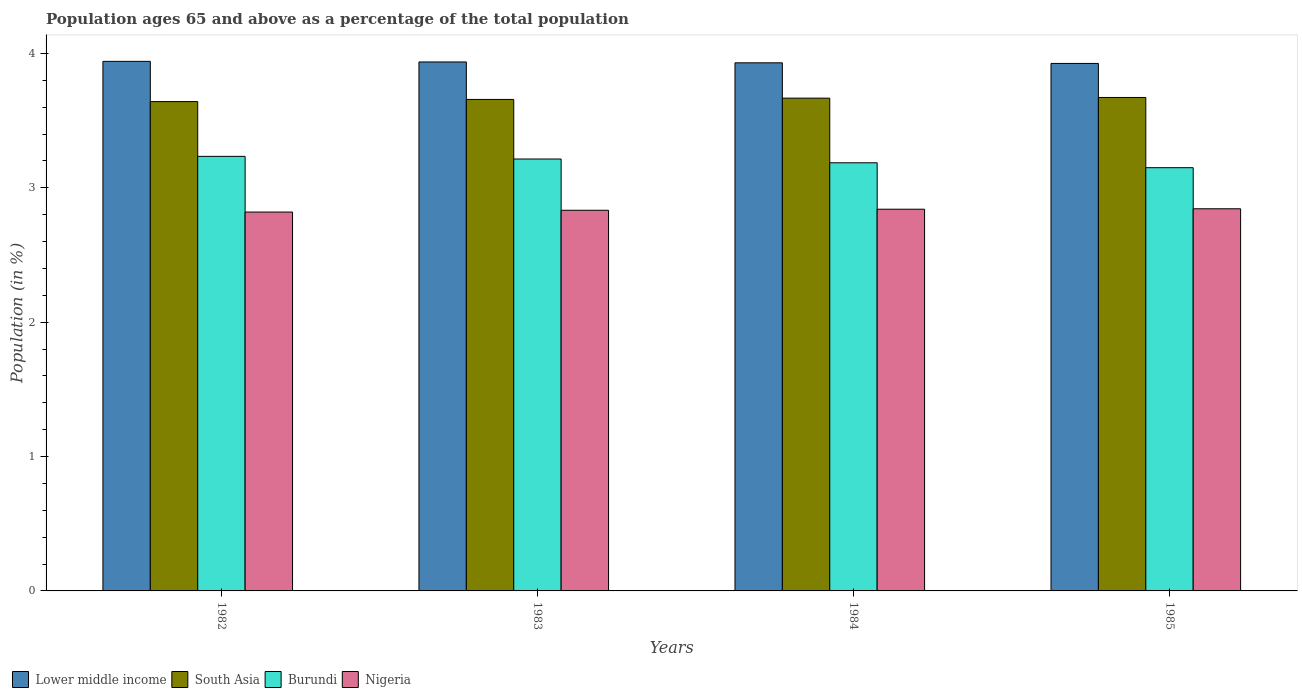How many bars are there on the 4th tick from the left?
Your answer should be very brief. 4. How many bars are there on the 1st tick from the right?
Provide a succinct answer. 4. What is the label of the 1st group of bars from the left?
Provide a short and direct response. 1982. In how many cases, is the number of bars for a given year not equal to the number of legend labels?
Offer a terse response. 0. What is the percentage of the population ages 65 and above in South Asia in 1985?
Make the answer very short. 3.67. Across all years, what is the maximum percentage of the population ages 65 and above in Burundi?
Provide a succinct answer. 3.23. Across all years, what is the minimum percentage of the population ages 65 and above in Burundi?
Your answer should be very brief. 3.15. In which year was the percentage of the population ages 65 and above in Lower middle income maximum?
Your answer should be very brief. 1982. What is the total percentage of the population ages 65 and above in Burundi in the graph?
Give a very brief answer. 12.78. What is the difference between the percentage of the population ages 65 and above in South Asia in 1983 and that in 1984?
Ensure brevity in your answer.  -0.01. What is the difference between the percentage of the population ages 65 and above in Lower middle income in 1983 and the percentage of the population ages 65 and above in Nigeria in 1984?
Provide a short and direct response. 1.1. What is the average percentage of the population ages 65 and above in South Asia per year?
Offer a terse response. 3.66. In the year 1985, what is the difference between the percentage of the population ages 65 and above in South Asia and percentage of the population ages 65 and above in Nigeria?
Your response must be concise. 0.83. What is the ratio of the percentage of the population ages 65 and above in South Asia in 1982 to that in 1985?
Give a very brief answer. 0.99. Is the percentage of the population ages 65 and above in Lower middle income in 1982 less than that in 1984?
Make the answer very short. No. What is the difference between the highest and the second highest percentage of the population ages 65 and above in Nigeria?
Give a very brief answer. 0. What is the difference between the highest and the lowest percentage of the population ages 65 and above in Nigeria?
Your answer should be very brief. 0.02. In how many years, is the percentage of the population ages 65 and above in Burundi greater than the average percentage of the population ages 65 and above in Burundi taken over all years?
Offer a very short reply. 2. What does the 3rd bar from the left in 1984 represents?
Your answer should be compact. Burundi. What does the 4th bar from the right in 1983 represents?
Provide a short and direct response. Lower middle income. Is it the case that in every year, the sum of the percentage of the population ages 65 and above in South Asia and percentage of the population ages 65 and above in Lower middle income is greater than the percentage of the population ages 65 and above in Burundi?
Make the answer very short. Yes. How many bars are there?
Your answer should be very brief. 16. Are all the bars in the graph horizontal?
Ensure brevity in your answer.  No. Does the graph contain grids?
Keep it short and to the point. No. How many legend labels are there?
Offer a terse response. 4. What is the title of the graph?
Make the answer very short. Population ages 65 and above as a percentage of the total population. Does "Fragile and conflict affected situations" appear as one of the legend labels in the graph?
Offer a very short reply. No. What is the label or title of the X-axis?
Keep it short and to the point. Years. What is the Population (in %) in Lower middle income in 1982?
Make the answer very short. 3.94. What is the Population (in %) in South Asia in 1982?
Keep it short and to the point. 3.64. What is the Population (in %) in Burundi in 1982?
Offer a terse response. 3.23. What is the Population (in %) in Nigeria in 1982?
Give a very brief answer. 2.82. What is the Population (in %) of Lower middle income in 1983?
Your answer should be compact. 3.94. What is the Population (in %) in South Asia in 1983?
Offer a very short reply. 3.66. What is the Population (in %) in Burundi in 1983?
Keep it short and to the point. 3.21. What is the Population (in %) of Nigeria in 1983?
Your answer should be very brief. 2.83. What is the Population (in %) of Lower middle income in 1984?
Your response must be concise. 3.93. What is the Population (in %) of South Asia in 1984?
Your response must be concise. 3.67. What is the Population (in %) in Burundi in 1984?
Make the answer very short. 3.19. What is the Population (in %) of Nigeria in 1984?
Your answer should be very brief. 2.84. What is the Population (in %) in Lower middle income in 1985?
Provide a succinct answer. 3.93. What is the Population (in %) in South Asia in 1985?
Give a very brief answer. 3.67. What is the Population (in %) in Burundi in 1985?
Your answer should be very brief. 3.15. What is the Population (in %) of Nigeria in 1985?
Keep it short and to the point. 2.84. Across all years, what is the maximum Population (in %) of Lower middle income?
Offer a terse response. 3.94. Across all years, what is the maximum Population (in %) of South Asia?
Make the answer very short. 3.67. Across all years, what is the maximum Population (in %) of Burundi?
Provide a succinct answer. 3.23. Across all years, what is the maximum Population (in %) in Nigeria?
Your answer should be very brief. 2.84. Across all years, what is the minimum Population (in %) of Lower middle income?
Offer a terse response. 3.93. Across all years, what is the minimum Population (in %) of South Asia?
Make the answer very short. 3.64. Across all years, what is the minimum Population (in %) in Burundi?
Provide a succinct answer. 3.15. Across all years, what is the minimum Population (in %) in Nigeria?
Give a very brief answer. 2.82. What is the total Population (in %) of Lower middle income in the graph?
Provide a succinct answer. 15.73. What is the total Population (in %) in South Asia in the graph?
Offer a terse response. 14.64. What is the total Population (in %) in Burundi in the graph?
Offer a terse response. 12.78. What is the total Population (in %) in Nigeria in the graph?
Ensure brevity in your answer.  11.34. What is the difference between the Population (in %) in Lower middle income in 1982 and that in 1983?
Ensure brevity in your answer.  0. What is the difference between the Population (in %) of South Asia in 1982 and that in 1983?
Your answer should be compact. -0.02. What is the difference between the Population (in %) of Burundi in 1982 and that in 1983?
Your response must be concise. 0.02. What is the difference between the Population (in %) of Nigeria in 1982 and that in 1983?
Your answer should be compact. -0.01. What is the difference between the Population (in %) in Lower middle income in 1982 and that in 1984?
Make the answer very short. 0.01. What is the difference between the Population (in %) in South Asia in 1982 and that in 1984?
Provide a succinct answer. -0.03. What is the difference between the Population (in %) in Burundi in 1982 and that in 1984?
Keep it short and to the point. 0.05. What is the difference between the Population (in %) of Nigeria in 1982 and that in 1984?
Offer a very short reply. -0.02. What is the difference between the Population (in %) of Lower middle income in 1982 and that in 1985?
Keep it short and to the point. 0.02. What is the difference between the Population (in %) of South Asia in 1982 and that in 1985?
Make the answer very short. -0.03. What is the difference between the Population (in %) in Burundi in 1982 and that in 1985?
Your answer should be compact. 0.08. What is the difference between the Population (in %) in Nigeria in 1982 and that in 1985?
Give a very brief answer. -0.02. What is the difference between the Population (in %) of Lower middle income in 1983 and that in 1984?
Make the answer very short. 0.01. What is the difference between the Population (in %) in South Asia in 1983 and that in 1984?
Keep it short and to the point. -0.01. What is the difference between the Population (in %) in Burundi in 1983 and that in 1984?
Ensure brevity in your answer.  0.03. What is the difference between the Population (in %) in Nigeria in 1983 and that in 1984?
Provide a short and direct response. -0.01. What is the difference between the Population (in %) of Lower middle income in 1983 and that in 1985?
Your answer should be compact. 0.01. What is the difference between the Population (in %) of South Asia in 1983 and that in 1985?
Offer a terse response. -0.01. What is the difference between the Population (in %) of Burundi in 1983 and that in 1985?
Keep it short and to the point. 0.06. What is the difference between the Population (in %) in Nigeria in 1983 and that in 1985?
Your answer should be very brief. -0.01. What is the difference between the Population (in %) in Lower middle income in 1984 and that in 1985?
Give a very brief answer. 0. What is the difference between the Population (in %) of South Asia in 1984 and that in 1985?
Ensure brevity in your answer.  -0.01. What is the difference between the Population (in %) in Burundi in 1984 and that in 1985?
Your response must be concise. 0.04. What is the difference between the Population (in %) in Nigeria in 1984 and that in 1985?
Provide a succinct answer. -0. What is the difference between the Population (in %) in Lower middle income in 1982 and the Population (in %) in South Asia in 1983?
Provide a succinct answer. 0.28. What is the difference between the Population (in %) of Lower middle income in 1982 and the Population (in %) of Burundi in 1983?
Your answer should be very brief. 0.73. What is the difference between the Population (in %) of Lower middle income in 1982 and the Population (in %) of Nigeria in 1983?
Your answer should be very brief. 1.11. What is the difference between the Population (in %) in South Asia in 1982 and the Population (in %) in Burundi in 1983?
Provide a short and direct response. 0.43. What is the difference between the Population (in %) in South Asia in 1982 and the Population (in %) in Nigeria in 1983?
Make the answer very short. 0.81. What is the difference between the Population (in %) of Burundi in 1982 and the Population (in %) of Nigeria in 1983?
Your answer should be very brief. 0.4. What is the difference between the Population (in %) in Lower middle income in 1982 and the Population (in %) in South Asia in 1984?
Provide a short and direct response. 0.27. What is the difference between the Population (in %) of Lower middle income in 1982 and the Population (in %) of Burundi in 1984?
Offer a very short reply. 0.75. What is the difference between the Population (in %) in Lower middle income in 1982 and the Population (in %) in Nigeria in 1984?
Make the answer very short. 1.1. What is the difference between the Population (in %) of South Asia in 1982 and the Population (in %) of Burundi in 1984?
Provide a short and direct response. 0.46. What is the difference between the Population (in %) in South Asia in 1982 and the Population (in %) in Nigeria in 1984?
Give a very brief answer. 0.8. What is the difference between the Population (in %) of Burundi in 1982 and the Population (in %) of Nigeria in 1984?
Ensure brevity in your answer.  0.39. What is the difference between the Population (in %) of Lower middle income in 1982 and the Population (in %) of South Asia in 1985?
Offer a terse response. 0.27. What is the difference between the Population (in %) in Lower middle income in 1982 and the Population (in %) in Burundi in 1985?
Offer a terse response. 0.79. What is the difference between the Population (in %) in Lower middle income in 1982 and the Population (in %) in Nigeria in 1985?
Keep it short and to the point. 1.1. What is the difference between the Population (in %) in South Asia in 1982 and the Population (in %) in Burundi in 1985?
Offer a very short reply. 0.49. What is the difference between the Population (in %) in South Asia in 1982 and the Population (in %) in Nigeria in 1985?
Ensure brevity in your answer.  0.8. What is the difference between the Population (in %) of Burundi in 1982 and the Population (in %) of Nigeria in 1985?
Ensure brevity in your answer.  0.39. What is the difference between the Population (in %) of Lower middle income in 1983 and the Population (in %) of South Asia in 1984?
Provide a short and direct response. 0.27. What is the difference between the Population (in %) of Lower middle income in 1983 and the Population (in %) of Burundi in 1984?
Make the answer very short. 0.75. What is the difference between the Population (in %) in Lower middle income in 1983 and the Population (in %) in Nigeria in 1984?
Your response must be concise. 1.1. What is the difference between the Population (in %) of South Asia in 1983 and the Population (in %) of Burundi in 1984?
Ensure brevity in your answer.  0.47. What is the difference between the Population (in %) of South Asia in 1983 and the Population (in %) of Nigeria in 1984?
Keep it short and to the point. 0.82. What is the difference between the Population (in %) of Burundi in 1983 and the Population (in %) of Nigeria in 1984?
Provide a short and direct response. 0.37. What is the difference between the Population (in %) of Lower middle income in 1983 and the Population (in %) of South Asia in 1985?
Keep it short and to the point. 0.26. What is the difference between the Population (in %) in Lower middle income in 1983 and the Population (in %) in Burundi in 1985?
Offer a very short reply. 0.79. What is the difference between the Population (in %) in Lower middle income in 1983 and the Population (in %) in Nigeria in 1985?
Provide a short and direct response. 1.09. What is the difference between the Population (in %) in South Asia in 1983 and the Population (in %) in Burundi in 1985?
Your answer should be compact. 0.51. What is the difference between the Population (in %) of South Asia in 1983 and the Population (in %) of Nigeria in 1985?
Keep it short and to the point. 0.81. What is the difference between the Population (in %) of Burundi in 1983 and the Population (in %) of Nigeria in 1985?
Provide a short and direct response. 0.37. What is the difference between the Population (in %) in Lower middle income in 1984 and the Population (in %) in South Asia in 1985?
Offer a very short reply. 0.26. What is the difference between the Population (in %) of Lower middle income in 1984 and the Population (in %) of Burundi in 1985?
Your answer should be compact. 0.78. What is the difference between the Population (in %) in Lower middle income in 1984 and the Population (in %) in Nigeria in 1985?
Your response must be concise. 1.09. What is the difference between the Population (in %) in South Asia in 1984 and the Population (in %) in Burundi in 1985?
Ensure brevity in your answer.  0.52. What is the difference between the Population (in %) in South Asia in 1984 and the Population (in %) in Nigeria in 1985?
Give a very brief answer. 0.82. What is the difference between the Population (in %) in Burundi in 1984 and the Population (in %) in Nigeria in 1985?
Keep it short and to the point. 0.34. What is the average Population (in %) of Lower middle income per year?
Provide a succinct answer. 3.93. What is the average Population (in %) of South Asia per year?
Your answer should be very brief. 3.66. What is the average Population (in %) of Burundi per year?
Offer a terse response. 3.2. What is the average Population (in %) of Nigeria per year?
Your answer should be compact. 2.83. In the year 1982, what is the difference between the Population (in %) in Lower middle income and Population (in %) in South Asia?
Offer a very short reply. 0.3. In the year 1982, what is the difference between the Population (in %) in Lower middle income and Population (in %) in Burundi?
Your answer should be very brief. 0.71. In the year 1982, what is the difference between the Population (in %) in Lower middle income and Population (in %) in Nigeria?
Offer a terse response. 1.12. In the year 1982, what is the difference between the Population (in %) of South Asia and Population (in %) of Burundi?
Offer a very short reply. 0.41. In the year 1982, what is the difference between the Population (in %) of South Asia and Population (in %) of Nigeria?
Your answer should be very brief. 0.82. In the year 1982, what is the difference between the Population (in %) in Burundi and Population (in %) in Nigeria?
Your answer should be very brief. 0.41. In the year 1983, what is the difference between the Population (in %) in Lower middle income and Population (in %) in South Asia?
Your answer should be compact. 0.28. In the year 1983, what is the difference between the Population (in %) in Lower middle income and Population (in %) in Burundi?
Ensure brevity in your answer.  0.72. In the year 1983, what is the difference between the Population (in %) of Lower middle income and Population (in %) of Nigeria?
Your answer should be compact. 1.1. In the year 1983, what is the difference between the Population (in %) in South Asia and Population (in %) in Burundi?
Offer a very short reply. 0.44. In the year 1983, what is the difference between the Population (in %) in South Asia and Population (in %) in Nigeria?
Keep it short and to the point. 0.82. In the year 1983, what is the difference between the Population (in %) of Burundi and Population (in %) of Nigeria?
Offer a terse response. 0.38. In the year 1984, what is the difference between the Population (in %) in Lower middle income and Population (in %) in South Asia?
Provide a short and direct response. 0.26. In the year 1984, what is the difference between the Population (in %) of Lower middle income and Population (in %) of Burundi?
Offer a terse response. 0.74. In the year 1984, what is the difference between the Population (in %) of Lower middle income and Population (in %) of Nigeria?
Offer a very short reply. 1.09. In the year 1984, what is the difference between the Population (in %) in South Asia and Population (in %) in Burundi?
Your answer should be compact. 0.48. In the year 1984, what is the difference between the Population (in %) in South Asia and Population (in %) in Nigeria?
Keep it short and to the point. 0.83. In the year 1984, what is the difference between the Population (in %) in Burundi and Population (in %) in Nigeria?
Provide a short and direct response. 0.35. In the year 1985, what is the difference between the Population (in %) of Lower middle income and Population (in %) of South Asia?
Offer a very short reply. 0.25. In the year 1985, what is the difference between the Population (in %) in Lower middle income and Population (in %) in Burundi?
Offer a very short reply. 0.78. In the year 1985, what is the difference between the Population (in %) of Lower middle income and Population (in %) of Nigeria?
Offer a terse response. 1.08. In the year 1985, what is the difference between the Population (in %) in South Asia and Population (in %) in Burundi?
Offer a terse response. 0.52. In the year 1985, what is the difference between the Population (in %) of South Asia and Population (in %) of Nigeria?
Offer a very short reply. 0.83. In the year 1985, what is the difference between the Population (in %) in Burundi and Population (in %) in Nigeria?
Provide a succinct answer. 0.31. What is the ratio of the Population (in %) of Nigeria in 1982 to that in 1983?
Your response must be concise. 1. What is the ratio of the Population (in %) of South Asia in 1982 to that in 1984?
Ensure brevity in your answer.  0.99. What is the ratio of the Population (in %) of Burundi in 1982 to that in 1984?
Offer a terse response. 1.01. What is the ratio of the Population (in %) in Lower middle income in 1982 to that in 1985?
Provide a succinct answer. 1. What is the ratio of the Population (in %) of Burundi in 1982 to that in 1985?
Your response must be concise. 1.03. What is the ratio of the Population (in %) of Nigeria in 1982 to that in 1985?
Keep it short and to the point. 0.99. What is the ratio of the Population (in %) of Burundi in 1983 to that in 1984?
Give a very brief answer. 1.01. What is the ratio of the Population (in %) of Lower middle income in 1983 to that in 1985?
Offer a very short reply. 1. What is the ratio of the Population (in %) of South Asia in 1983 to that in 1985?
Give a very brief answer. 1. What is the ratio of the Population (in %) in Burundi in 1983 to that in 1985?
Keep it short and to the point. 1.02. What is the ratio of the Population (in %) in Burundi in 1984 to that in 1985?
Your answer should be compact. 1.01. What is the difference between the highest and the second highest Population (in %) in Lower middle income?
Provide a succinct answer. 0. What is the difference between the highest and the second highest Population (in %) of South Asia?
Give a very brief answer. 0.01. What is the difference between the highest and the second highest Population (in %) of Burundi?
Provide a short and direct response. 0.02. What is the difference between the highest and the second highest Population (in %) in Nigeria?
Your answer should be compact. 0. What is the difference between the highest and the lowest Population (in %) in Lower middle income?
Offer a very short reply. 0.02. What is the difference between the highest and the lowest Population (in %) in South Asia?
Make the answer very short. 0.03. What is the difference between the highest and the lowest Population (in %) in Burundi?
Your response must be concise. 0.08. What is the difference between the highest and the lowest Population (in %) of Nigeria?
Keep it short and to the point. 0.02. 